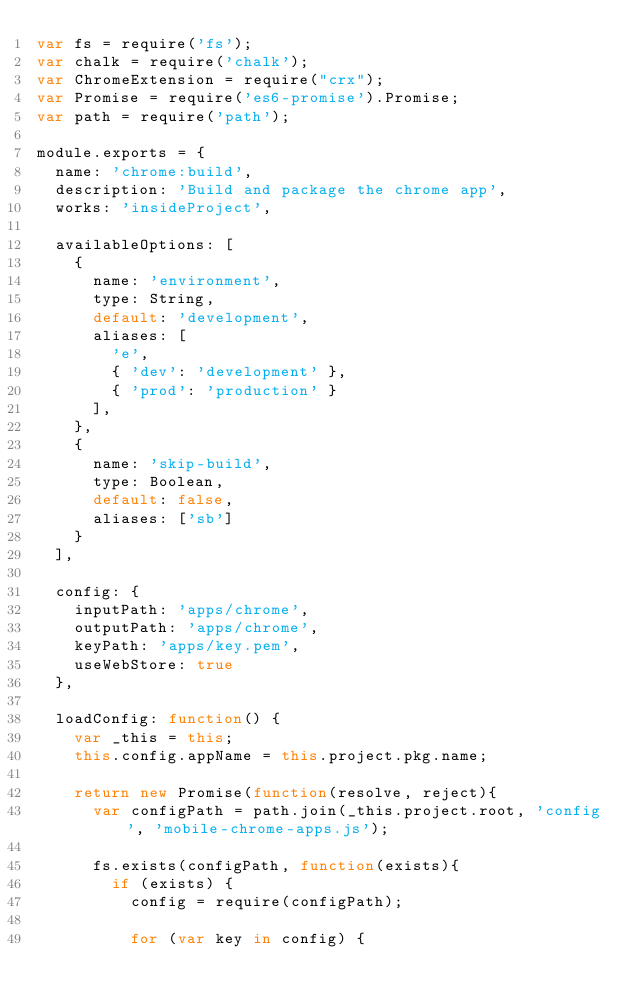Convert code to text. <code><loc_0><loc_0><loc_500><loc_500><_JavaScript_>var fs = require('fs');
var chalk = require('chalk');
var ChromeExtension = require("crx");
var Promise = require('es6-promise').Promise;
var path = require('path');

module.exports = {
  name: 'chrome:build',
  description: 'Build and package the chrome app',
  works: 'insideProject',

  availableOptions: [
    {
      name: 'environment',
      type: String,
      default: 'development',
      aliases: [
        'e',
        { 'dev': 'development' },
        { 'prod': 'production' }
      ],
    },
    {
      name: 'skip-build',
      type: Boolean,
      default: false,
      aliases: ['sb']
    }
  ],

  config: {
    inputPath: 'apps/chrome',
    outputPath: 'apps/chrome',
    keyPath: 'apps/key.pem',
    useWebStore: true
  },

  loadConfig: function() {
    var _this = this;
    this.config.appName = this.project.pkg.name;

    return new Promise(function(resolve, reject){
      var configPath = path.join(_this.project.root, 'config', 'mobile-chrome-apps.js');

      fs.exists(configPath, function(exists){
        if (exists) {
          config = require(configPath);

          for (var key in config) {</code> 